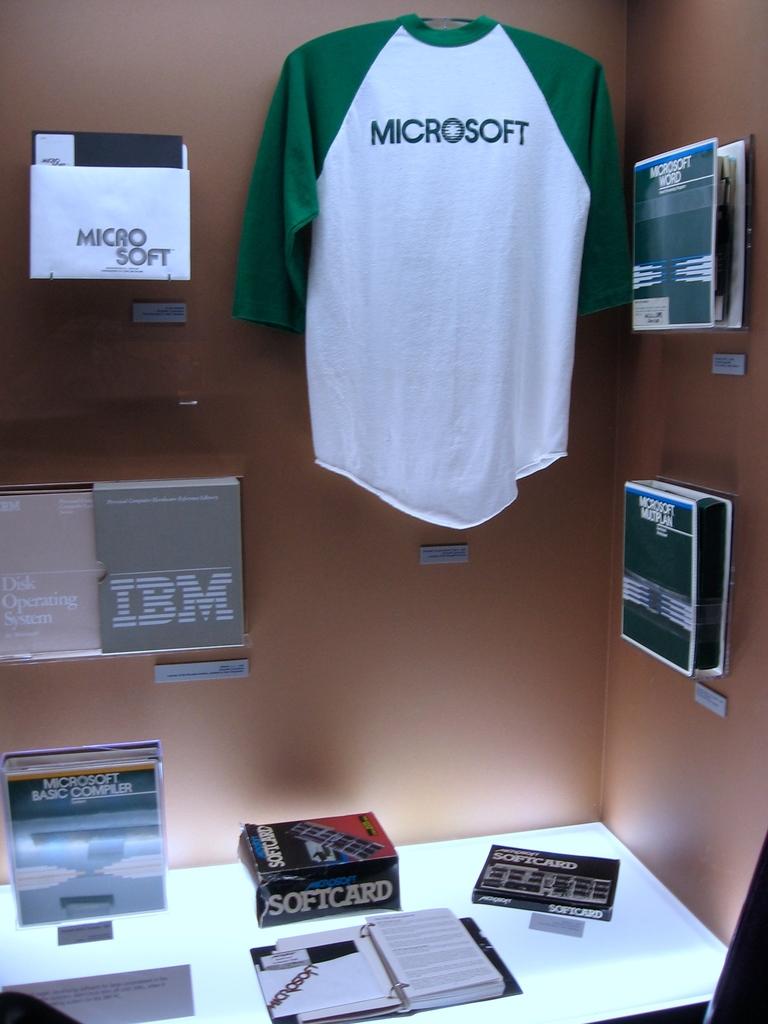What team is on the shirt in the office?
Offer a terse response. Microsoft. Is an ibm product shown here?
Offer a very short reply. Yes. 